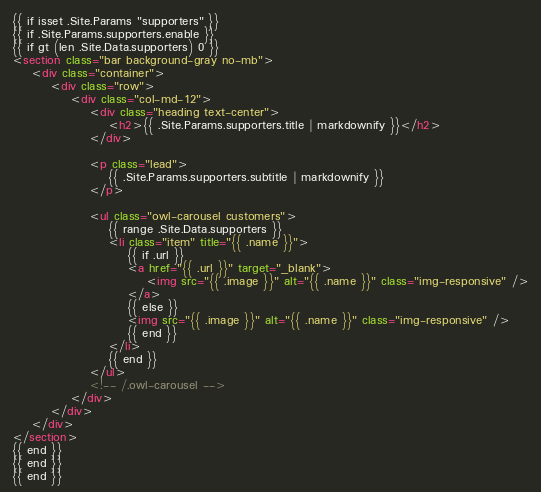<code> <loc_0><loc_0><loc_500><loc_500><_HTML_>{{ if isset .Site.Params "supporters" }}
{{ if .Site.Params.supporters.enable }}
{{ if gt (len .Site.Data.supporters) 0 }}
<section class="bar background-gray no-mb">
    <div class="container">
        <div class="row">
            <div class="col-md-12">
                <div class="heading text-center">
                    <h2>{{ .Site.Params.supporters.title | markdownify }}</h2>
                </div>

                <p class="lead">
                    {{ .Site.Params.supporters.subtitle | markdownify }}
                </p>

                <ul class="owl-carousel customers">
                    {{ range .Site.Data.supporters }}
                    <li class="item" title="{{ .name }}">
                        {{ if .url }}
                        <a href="{{ .url }}" target="_blank">
                            <img src="{{ .image }}" alt="{{ .name }}" class="img-responsive" />
                        </a>
                        {{ else }}
                        <img src="{{ .image }}" alt="{{ .name }}" class="img-responsive" />
                        {{ end }}
                    </li>
                    {{ end }}
                </ul>
                <!-- /.owl-carousel -->
            </div>
        </div>
    </div>
</section>
{{ end }}
{{ end }}
{{ end }}
</code> 